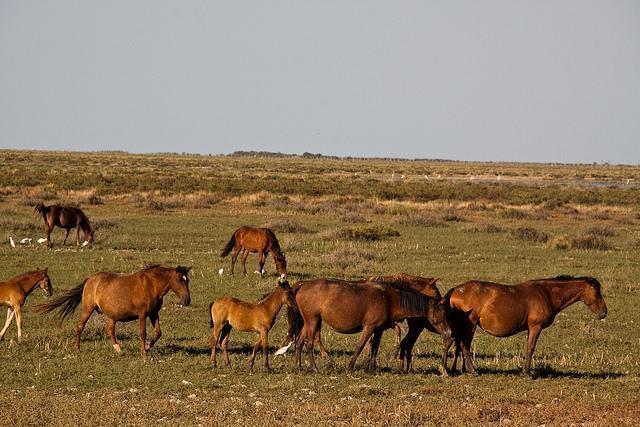What type of land are the horses found on?
Answer the question by selecting the correct answer among the 4 following choices.
Options: Mountains, plains, hills, gulfs. Plains. 